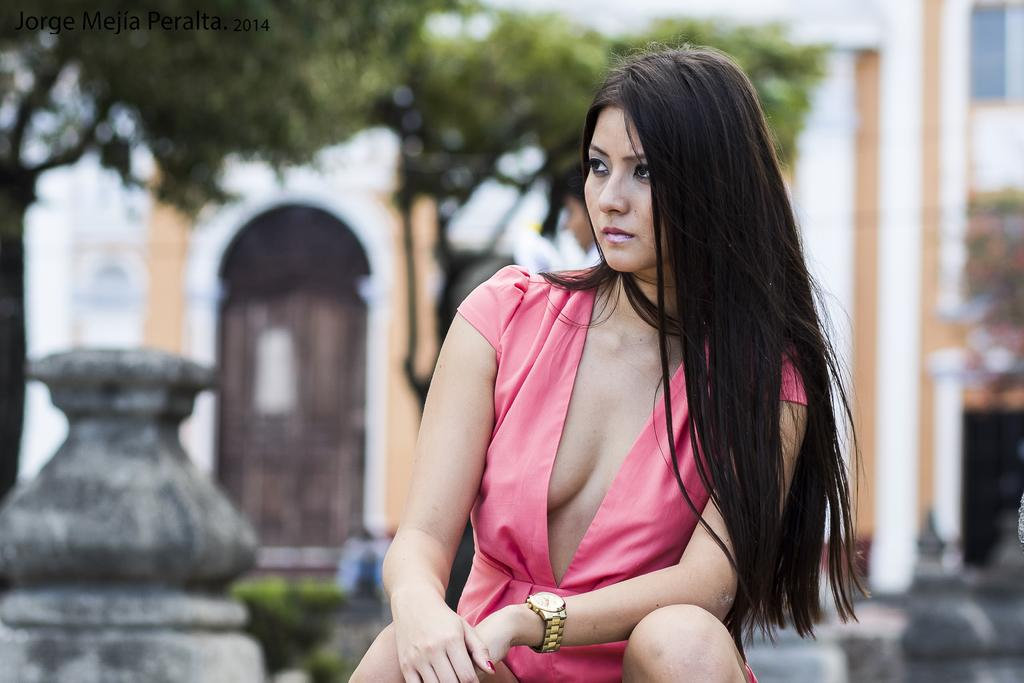Who is present in the image? There is a woman in the image. What is the woman wearing? The woman is wearing a pink dress. What is the woman doing in the image? The woman is sitting. In which direction is the woman looking? The woman is looking to the left side. What can be seen in the background of the image? There is a building and a tree in the background of the image. What type of doll is the woman holding in the image? There is no doll present in the image; the woman is not holding anything. Can you tell me how many turkeys are visible in the image? There are no turkeys present in the image. 